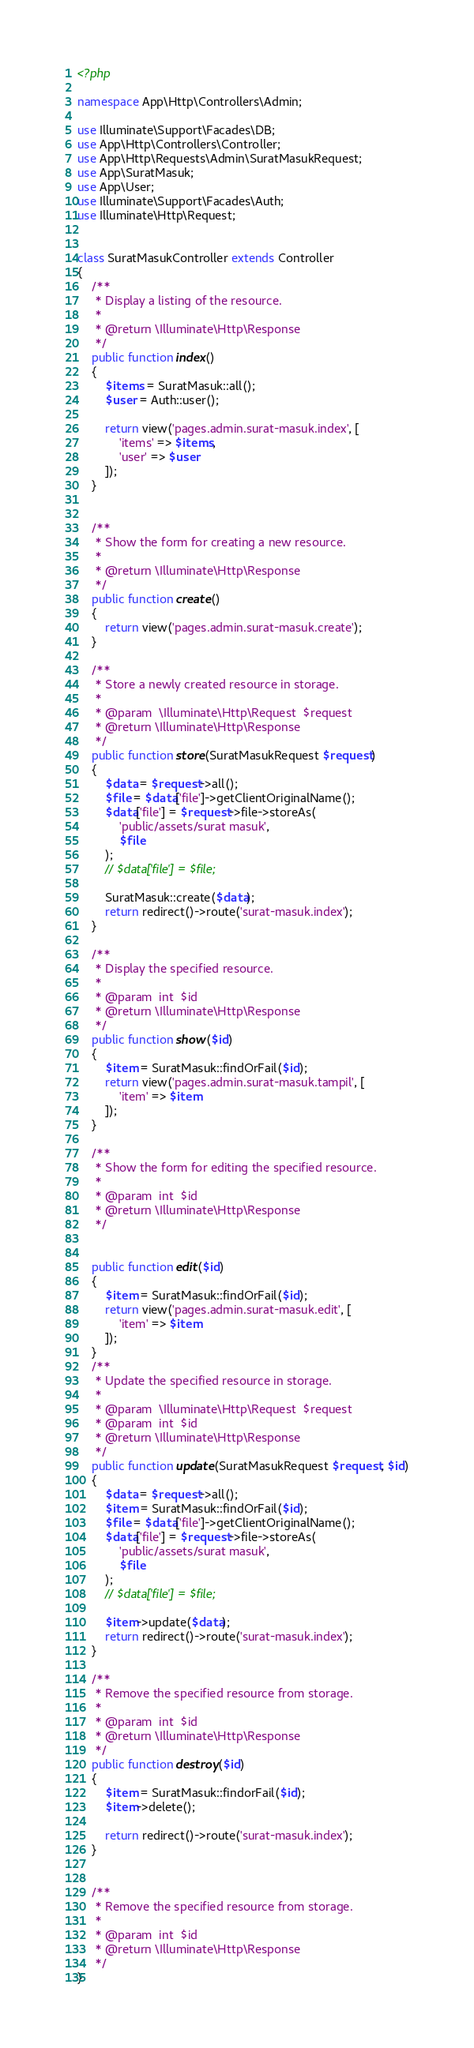Convert code to text. <code><loc_0><loc_0><loc_500><loc_500><_PHP_><?php

namespace App\Http\Controllers\Admin;

use Illuminate\Support\Facades\DB;
use App\Http\Controllers\Controller;
use App\Http\Requests\Admin\SuratMasukRequest;
use App\SuratMasuk;
use App\User;
use Illuminate\Support\Facades\Auth;
use Illuminate\Http\Request;


class SuratMasukController extends Controller
{
    /**
     * Display a listing of the resource.
     *
     * @return \Illuminate\Http\Response
     */
    public function index()
    {
        $items = SuratMasuk::all();
        $user = Auth::user();

        return view('pages.admin.surat-masuk.index', [
            'items' => $items,
            'user' => $user
        ]);
    }


    /**
     * Show the form for creating a new resource.
     *
     * @return \Illuminate\Http\Response
     */
    public function create()
    {
        return view('pages.admin.surat-masuk.create');
    }

    /**
     * Store a newly created resource in storage.
     *
     * @param  \Illuminate\Http\Request  $request
     * @return \Illuminate\Http\Response
     */
    public function store(SuratMasukRequest $request)
    {
        $data = $request->all();
        $file = $data['file']->getClientOriginalName();
        $data['file'] = $request->file->storeAs(
            'public/assets/surat masuk',
            $file
        );
        // $data['file'] = $file;

        SuratMasuk::create($data);
        return redirect()->route('surat-masuk.index');
    }

    /**
     * Display the specified resource.
     *
     * @param  int  $id
     * @return \Illuminate\Http\Response
     */
    public function show($id)
    {
        $item = SuratMasuk::findOrFail($id);
        return view('pages.admin.surat-masuk.tampil', [
            'item' => $item
        ]);
    }

    /**
     * Show the form for editing the specified resource.
     *
     * @param  int  $id
     * @return \Illuminate\Http\Response
     */


    public function edit($id)
    {
        $item = SuratMasuk::findOrFail($id);
        return view('pages.admin.surat-masuk.edit', [
            'item' => $item
        ]);
    }
    /**
     * Update the specified resource in storage.
     *
     * @param  \Illuminate\Http\Request  $request
     * @param  int  $id
     * @return \Illuminate\Http\Response
     */
    public function update(SuratMasukRequest $request, $id)
    {
        $data = $request->all();
        $item = SuratMasuk::findOrFail($id);
        $file = $data['file']->getClientOriginalName();
        $data['file'] = $request->file->storeAs(
            'public/assets/surat masuk',
            $file
        );
        // $data['file'] = $file;

        $item->update($data);
        return redirect()->route('surat-masuk.index');
    }

    /**
     * Remove the specified resource from storage.
     *
     * @param  int  $id
     * @return \Illuminate\Http\Response
     */
    public function destroy($id)
    {
        $item = SuratMasuk::findorFail($id);
        $item->delete();

        return redirect()->route('surat-masuk.index');
    }


    /**
     * Remove the specified resource from storage.
     *
     * @param  int  $id
     * @return \Illuminate\Http\Response
     */
}
</code> 